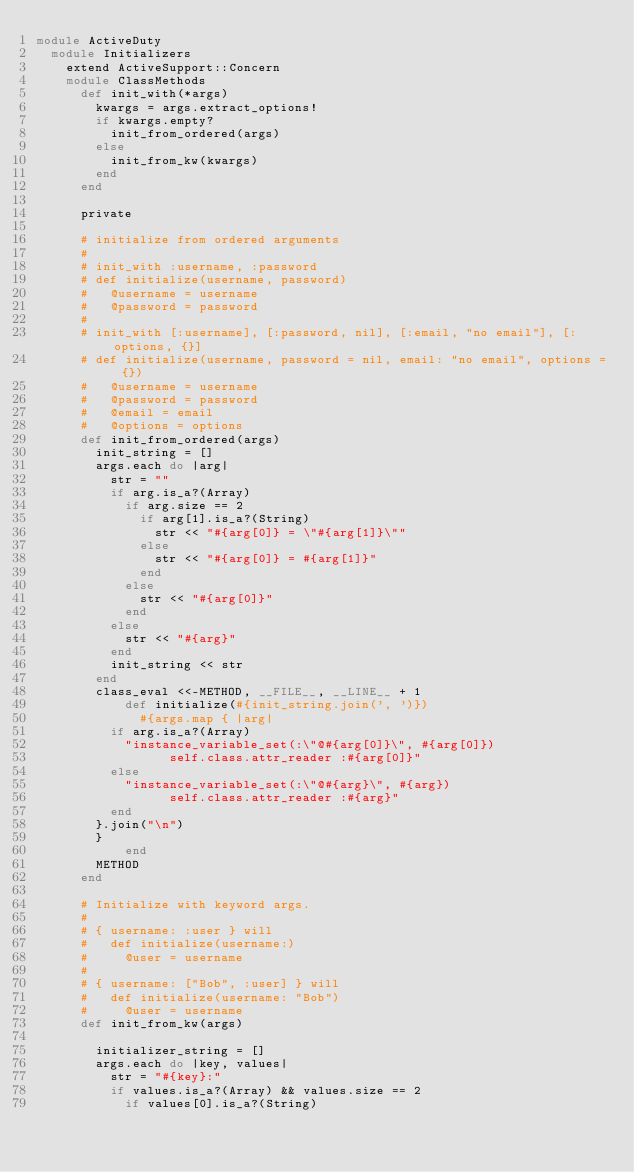Convert code to text. <code><loc_0><loc_0><loc_500><loc_500><_Ruby_>module ActiveDuty
  module Initializers
    extend ActiveSupport::Concern
    module ClassMethods
      def init_with(*args)
        kwargs = args.extract_options!
        if kwargs.empty?
          init_from_ordered(args)
        else
          init_from_kw(kwargs)
        end
      end

      private

      # initialize from ordered arguments
      #
      # init_with :username, :password
      # def initialize(username, password)
      #   @username = username
      #   @password = password
      #
      # init_with [:username], [:password, nil], [:email, "no email"], [:options, {}]
      # def initialize(username, password = nil, email: "no email", options = {})
      #   @username = username
      #   @password = password
      #   @email = email
      #   @options = options
      def init_from_ordered(args)
        init_string = []
        args.each do |arg|
          str = ""
          if arg.is_a?(Array)
            if arg.size == 2
              if arg[1].is_a?(String)
                str << "#{arg[0]} = \"#{arg[1]}\""
              else
                str << "#{arg[0]} = #{arg[1]}"
              end
            else
              str << "#{arg[0]}"
            end
          else
            str << "#{arg}"
          end
          init_string << str
        end
        class_eval <<-METHOD, __FILE__, __LINE__ + 1
            def initialize(#{init_string.join(', ')})
              #{args.map { |arg|
          if arg.is_a?(Array)
            "instance_variable_set(:\"@#{arg[0]}\", #{arg[0]}) 
                  self.class.attr_reader :#{arg[0]}"
          else
            "instance_variable_set(:\"@#{arg}\", #{arg}) 
                  self.class.attr_reader :#{arg}"
          end
        }.join("\n")
        }
            end
        METHOD
      end

      # Initialize with keyword args.
      #
      # { username: :user } will
      #   def initialize(username:)
      #     @user = username
      #
      # { username: ["Bob", :user] } will
      #   def initialize(username: "Bob")
      #     @user = username
      def init_from_kw(args)

        initializer_string = []
        args.each do |key, values|
          str = "#{key}:"
          if values.is_a?(Array) && values.size == 2
            if values[0].is_a?(String)</code> 